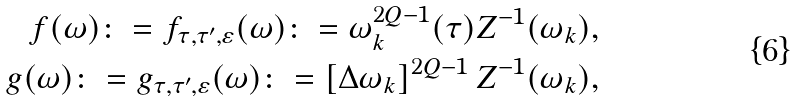Convert formula to latex. <formula><loc_0><loc_0><loc_500><loc_500>f ( \omega ) \colon = f _ { \tau , \tau ^ { \prime } , \varepsilon } ( \omega ) \colon = \omega _ { k } ^ { 2 Q - 1 } ( \tau ) Z ^ { - 1 } ( \omega _ { k } ) , \\ g ( \omega ) \colon = g _ { \tau , \tau ^ { \prime } , \varepsilon } ( \omega ) \colon = \left [ \Delta \omega _ { k } \right ] ^ { 2 Q - 1 } Z ^ { - 1 } ( \omega _ { k } ) ,</formula> 